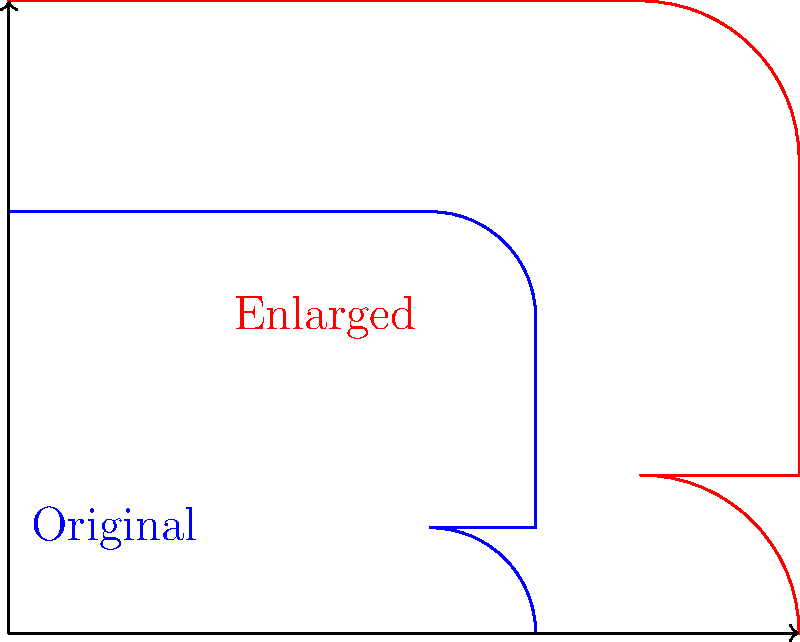As an experienced horseman, you're tasked with expanding your training area. The current racetrack, shown in blue, needs to be enlarged to accommodate more horses. If you want to create a new track (shown in red) that is 1.5 times larger in all dimensions, what translation vector would you use to move the top-right corner of the original track to its new position on the enlarged track? To solve this problem, we need to follow these steps:

1) First, let's identify the top-right corner of the original track. From the diagram, we can see it's at coordinates (5,4).

2) Now, we need to determine where this point will be on the enlarged track. Since the new track is 1.5 times larger in all dimensions:
   - The x-coordinate will change from 5 to $5 * 1.5 = 7.5$
   - The y-coordinate will change from 4 to $4 * 1.5 = 6$

3) So, the new position of the top-right corner will be (7.5, 6).

4) To find the translation vector, we need to calculate the difference between the new and original positions:
   - x-component: $7.5 - 5 = 2.5$
   - y-component: $6 - 4 = 2$

5) Therefore, the translation vector is $\langle 2.5, 2 \rangle$.

This vector represents the movement needed to shift the top-right corner of the original track to its new position on the enlarged track.
Answer: $\langle 2.5, 2 \rangle$ 